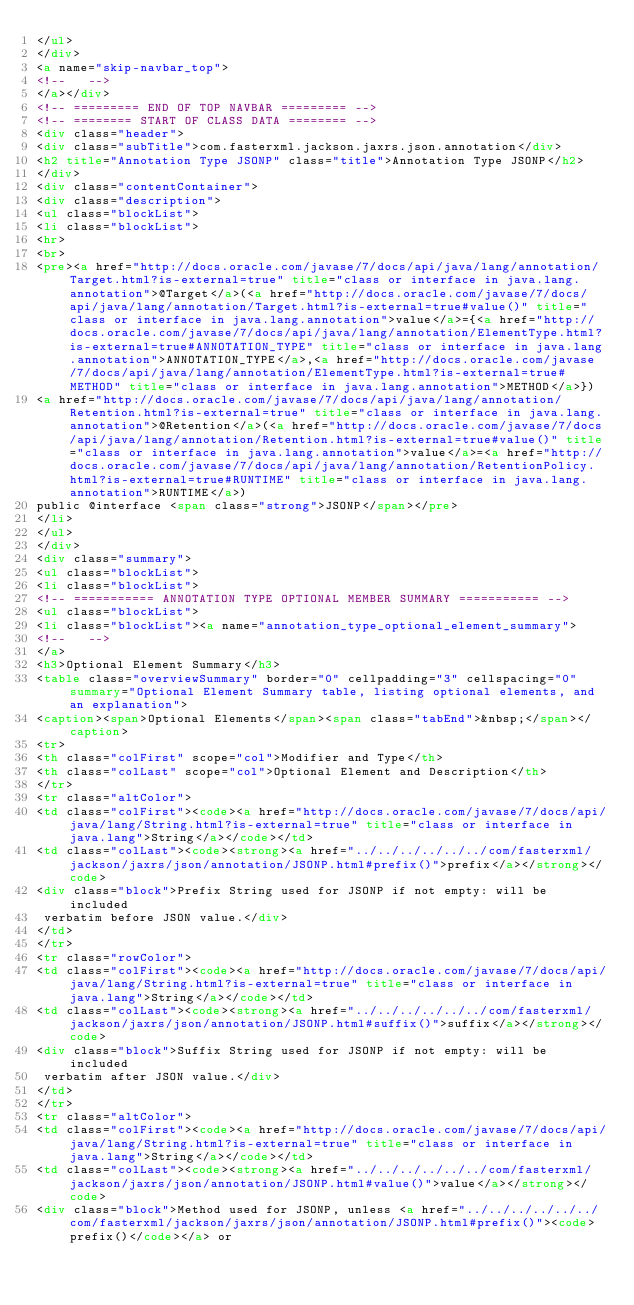Convert code to text. <code><loc_0><loc_0><loc_500><loc_500><_HTML_></ul>
</div>
<a name="skip-navbar_top">
<!--   -->
</a></div>
<!-- ========= END OF TOP NAVBAR ========= -->
<!-- ======== START OF CLASS DATA ======== -->
<div class="header">
<div class="subTitle">com.fasterxml.jackson.jaxrs.json.annotation</div>
<h2 title="Annotation Type JSONP" class="title">Annotation Type JSONP</h2>
</div>
<div class="contentContainer">
<div class="description">
<ul class="blockList">
<li class="blockList">
<hr>
<br>
<pre><a href="http://docs.oracle.com/javase/7/docs/api/java/lang/annotation/Target.html?is-external=true" title="class or interface in java.lang.annotation">@Target</a>(<a href="http://docs.oracle.com/javase/7/docs/api/java/lang/annotation/Target.html?is-external=true#value()" title="class or interface in java.lang.annotation">value</a>={<a href="http://docs.oracle.com/javase/7/docs/api/java/lang/annotation/ElementType.html?is-external=true#ANNOTATION_TYPE" title="class or interface in java.lang.annotation">ANNOTATION_TYPE</a>,<a href="http://docs.oracle.com/javase/7/docs/api/java/lang/annotation/ElementType.html?is-external=true#METHOD" title="class or interface in java.lang.annotation">METHOD</a>})
<a href="http://docs.oracle.com/javase/7/docs/api/java/lang/annotation/Retention.html?is-external=true" title="class or interface in java.lang.annotation">@Retention</a>(<a href="http://docs.oracle.com/javase/7/docs/api/java/lang/annotation/Retention.html?is-external=true#value()" title="class or interface in java.lang.annotation">value</a>=<a href="http://docs.oracle.com/javase/7/docs/api/java/lang/annotation/RetentionPolicy.html?is-external=true#RUNTIME" title="class or interface in java.lang.annotation">RUNTIME</a>)
public @interface <span class="strong">JSONP</span></pre>
</li>
</ul>
</div>
<div class="summary">
<ul class="blockList">
<li class="blockList">
<!-- =========== ANNOTATION TYPE OPTIONAL MEMBER SUMMARY =========== -->
<ul class="blockList">
<li class="blockList"><a name="annotation_type_optional_element_summary">
<!--   -->
</a>
<h3>Optional Element Summary</h3>
<table class="overviewSummary" border="0" cellpadding="3" cellspacing="0" summary="Optional Element Summary table, listing optional elements, and an explanation">
<caption><span>Optional Elements</span><span class="tabEnd">&nbsp;</span></caption>
<tr>
<th class="colFirst" scope="col">Modifier and Type</th>
<th class="colLast" scope="col">Optional Element and Description</th>
</tr>
<tr class="altColor">
<td class="colFirst"><code><a href="http://docs.oracle.com/javase/7/docs/api/java/lang/String.html?is-external=true" title="class or interface in java.lang">String</a></code></td>
<td class="colLast"><code><strong><a href="../../../../../../com/fasterxml/jackson/jaxrs/json/annotation/JSONP.html#prefix()">prefix</a></strong></code>
<div class="block">Prefix String used for JSONP if not empty: will be included
 verbatim before JSON value.</div>
</td>
</tr>
<tr class="rowColor">
<td class="colFirst"><code><a href="http://docs.oracle.com/javase/7/docs/api/java/lang/String.html?is-external=true" title="class or interface in java.lang">String</a></code></td>
<td class="colLast"><code><strong><a href="../../../../../../com/fasterxml/jackson/jaxrs/json/annotation/JSONP.html#suffix()">suffix</a></strong></code>
<div class="block">Suffix String used for JSONP if not empty: will be included
 verbatim after JSON value.</div>
</td>
</tr>
<tr class="altColor">
<td class="colFirst"><code><a href="http://docs.oracle.com/javase/7/docs/api/java/lang/String.html?is-external=true" title="class or interface in java.lang">String</a></code></td>
<td class="colLast"><code><strong><a href="../../../../../../com/fasterxml/jackson/jaxrs/json/annotation/JSONP.html#value()">value</a></strong></code>
<div class="block">Method used for JSONP, unless <a href="../../../../../../com/fasterxml/jackson/jaxrs/json/annotation/JSONP.html#prefix()"><code>prefix()</code></a> or</code> 